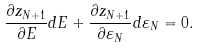<formula> <loc_0><loc_0><loc_500><loc_500>\frac { \partial z _ { N + 1 } } { \partial E } d E + \frac { \partial z _ { N + 1 } } { \partial \varepsilon _ { N } } d \varepsilon _ { N } = 0 .</formula> 